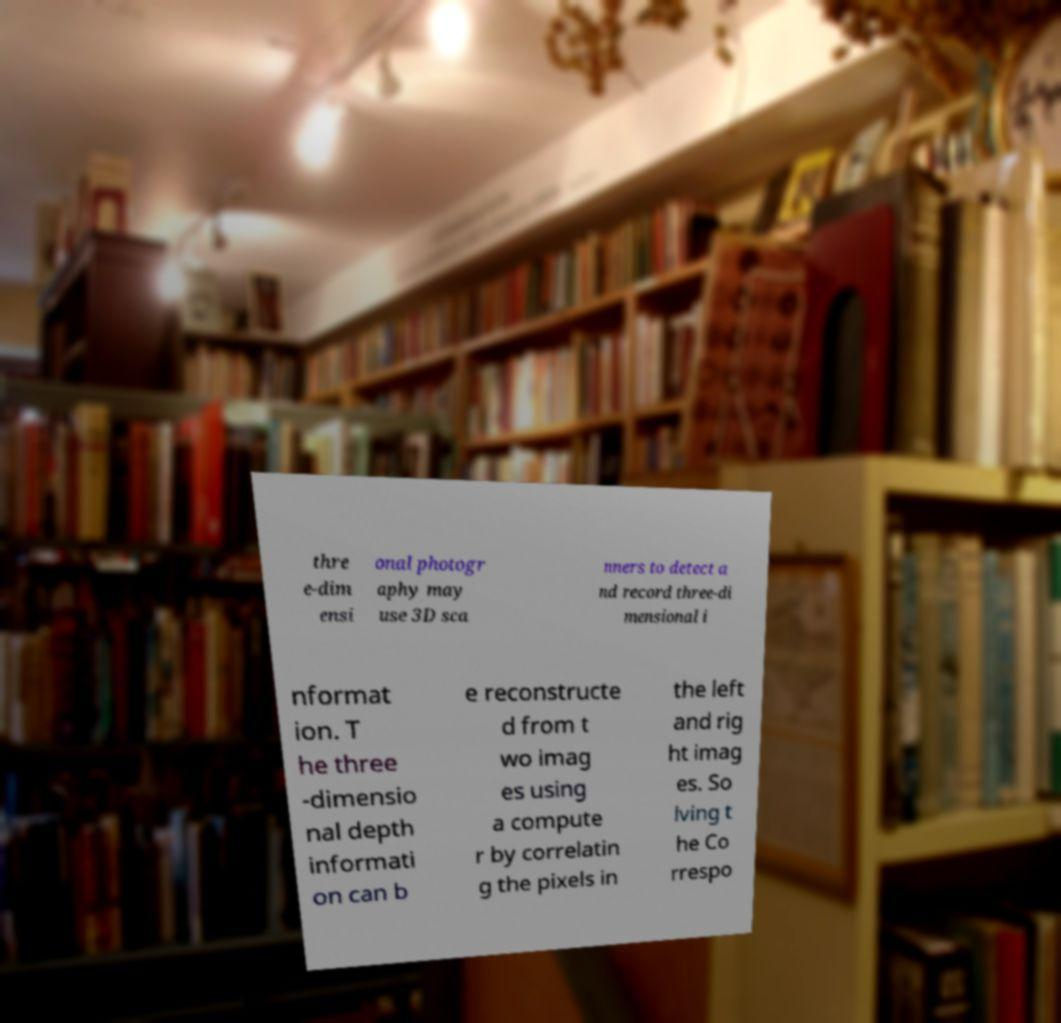For documentation purposes, I need the text within this image transcribed. Could you provide that? thre e-dim ensi onal photogr aphy may use 3D sca nners to detect a nd record three-di mensional i nformat ion. T he three -dimensio nal depth informati on can b e reconstructe d from t wo imag es using a compute r by correlatin g the pixels in the left and rig ht imag es. So lving t he Co rrespo 